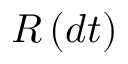<formula> <loc_0><loc_0><loc_500><loc_500>R \left ( d t \right )</formula> 